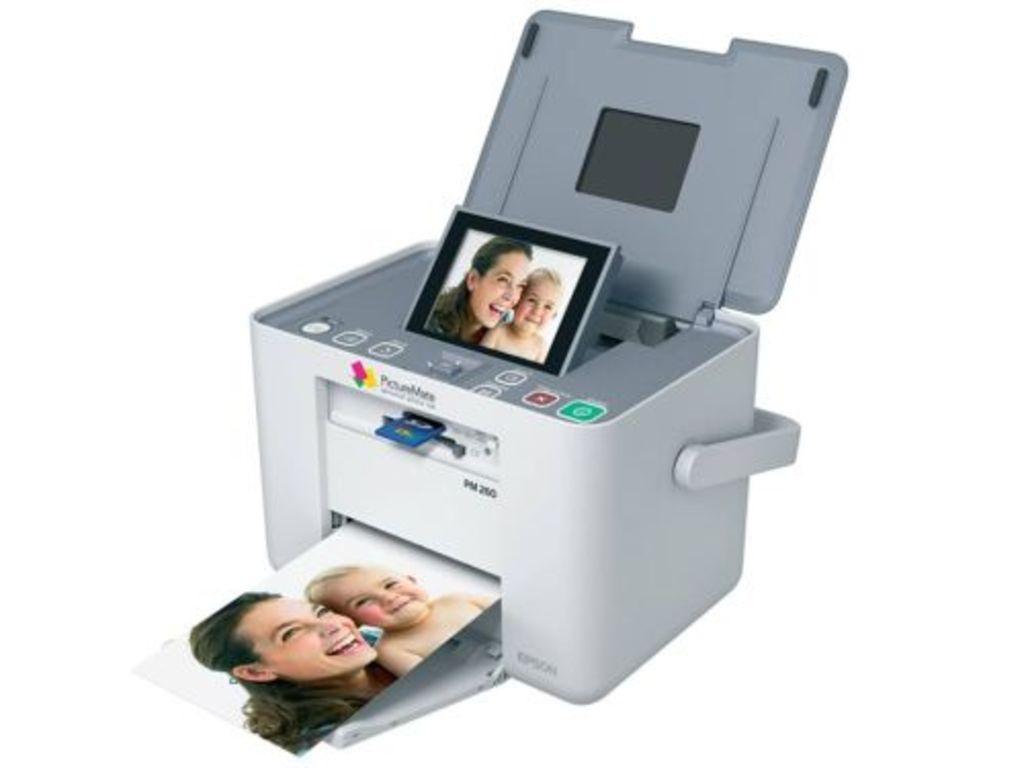Describe this image in one or two sentences. In the image we can see the printer and photos. In the photo we can see a woman and a baby smiling. 